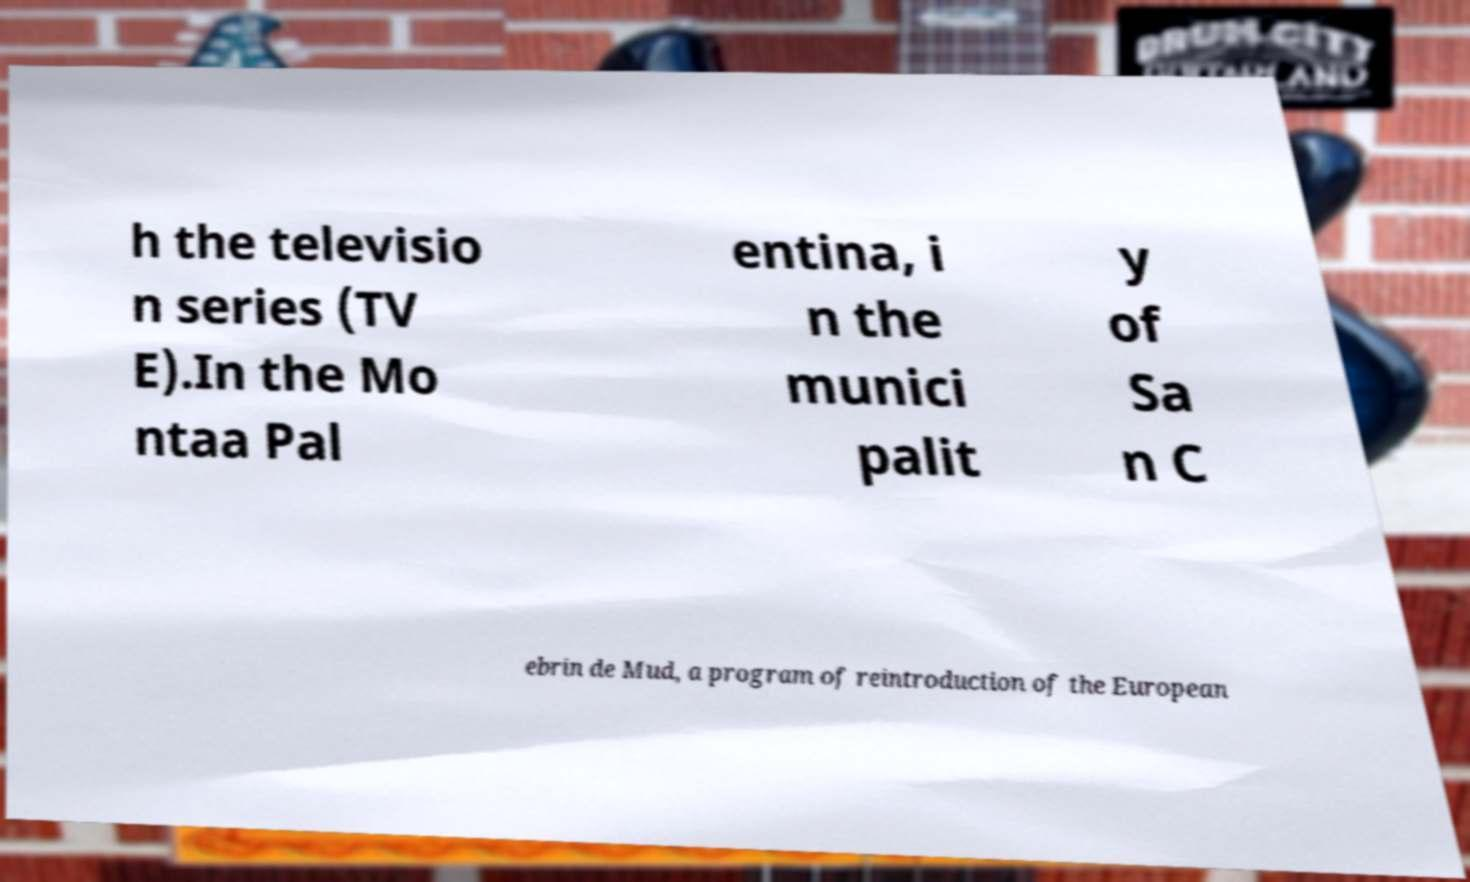Can you read and provide the text displayed in the image?This photo seems to have some interesting text. Can you extract and type it out for me? h the televisio n series (TV E).In the Mo ntaa Pal entina, i n the munici palit y of Sa n C ebrin de Mud, a program of reintroduction of the European 